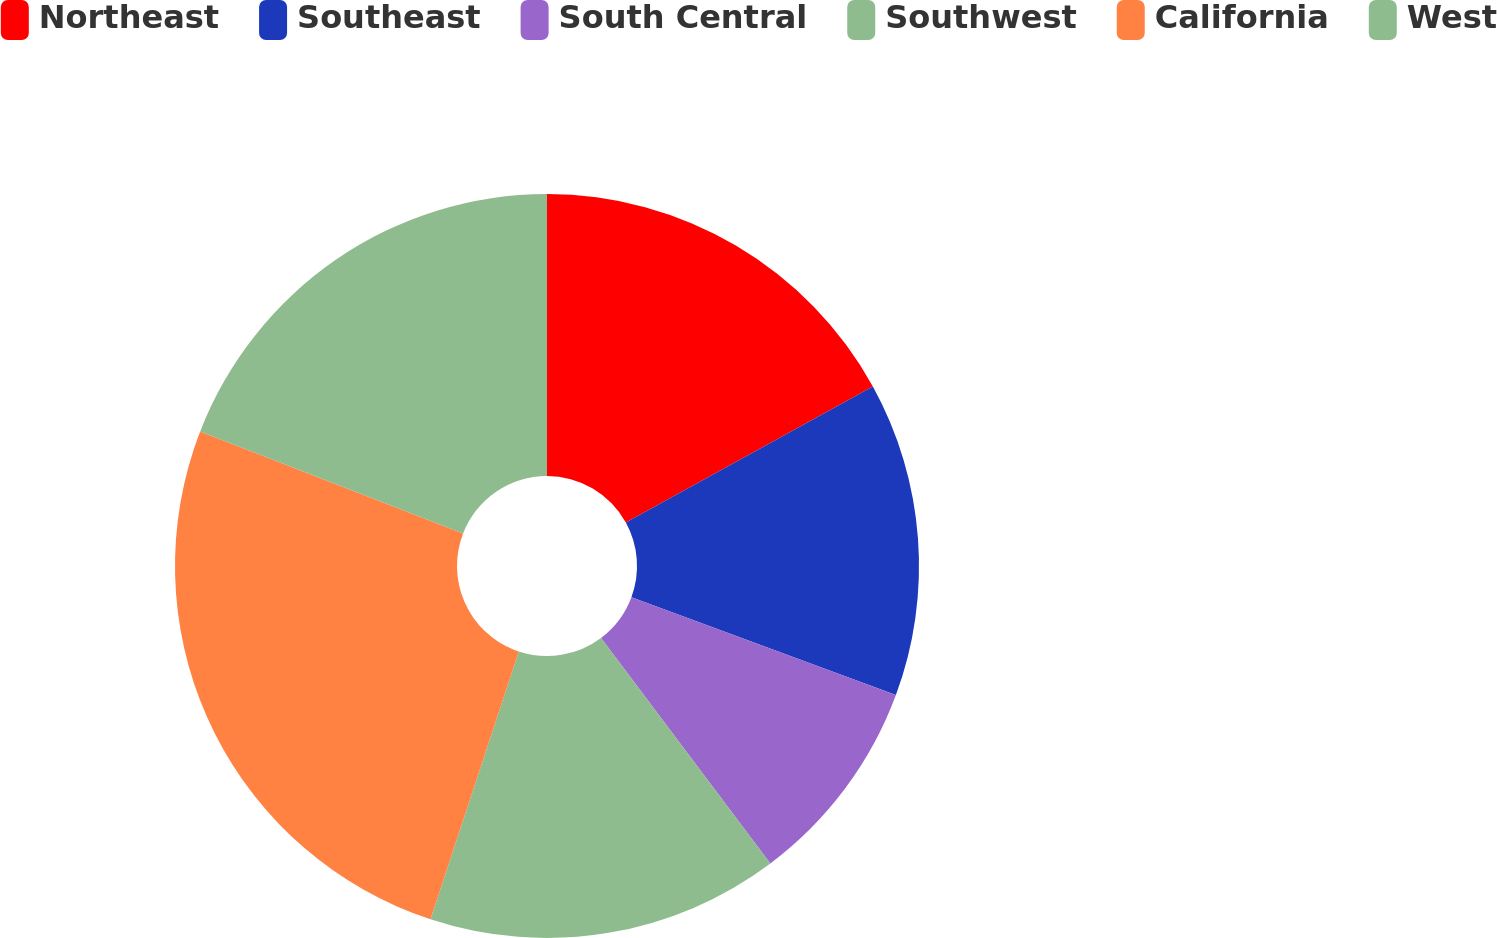<chart> <loc_0><loc_0><loc_500><loc_500><pie_chart><fcel>Northeast<fcel>Southeast<fcel>South Central<fcel>Southwest<fcel>California<fcel>West<nl><fcel>16.99%<fcel>13.65%<fcel>9.11%<fcel>15.32%<fcel>25.82%<fcel>19.11%<nl></chart> 